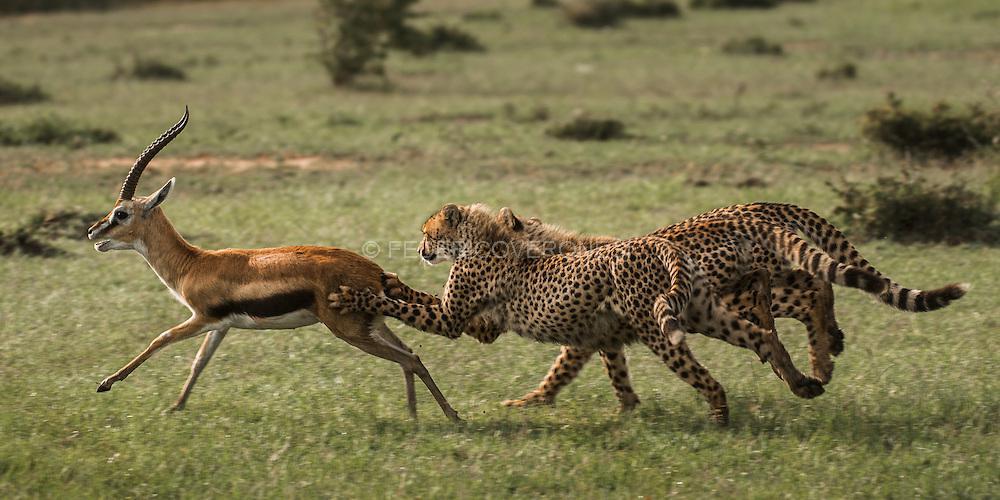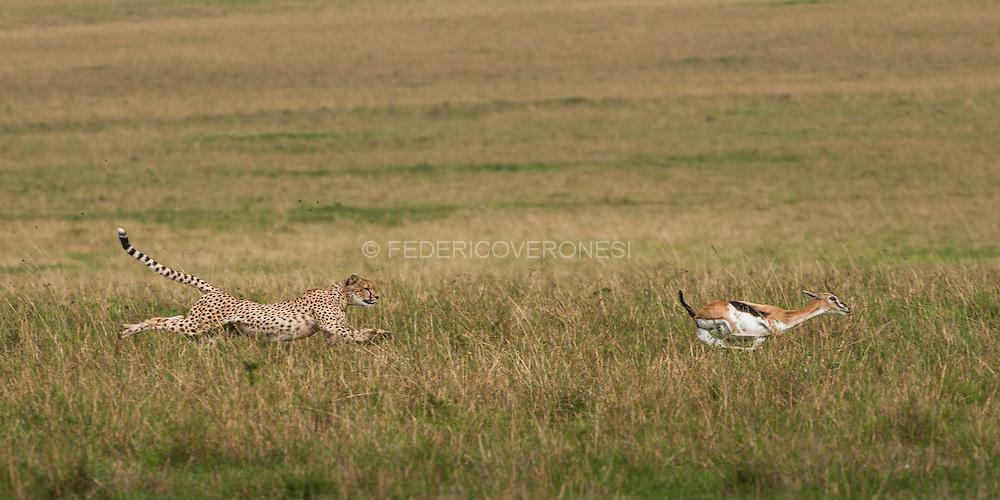The first image is the image on the left, the second image is the image on the right. For the images shown, is this caption "The sky is visible in the background of at least one of the images." true? Answer yes or no. No. The first image is the image on the left, the second image is the image on the right. Analyze the images presented: Is the assertion "One of the cheetahs is touching its prey." valid? Answer yes or no. Yes. 